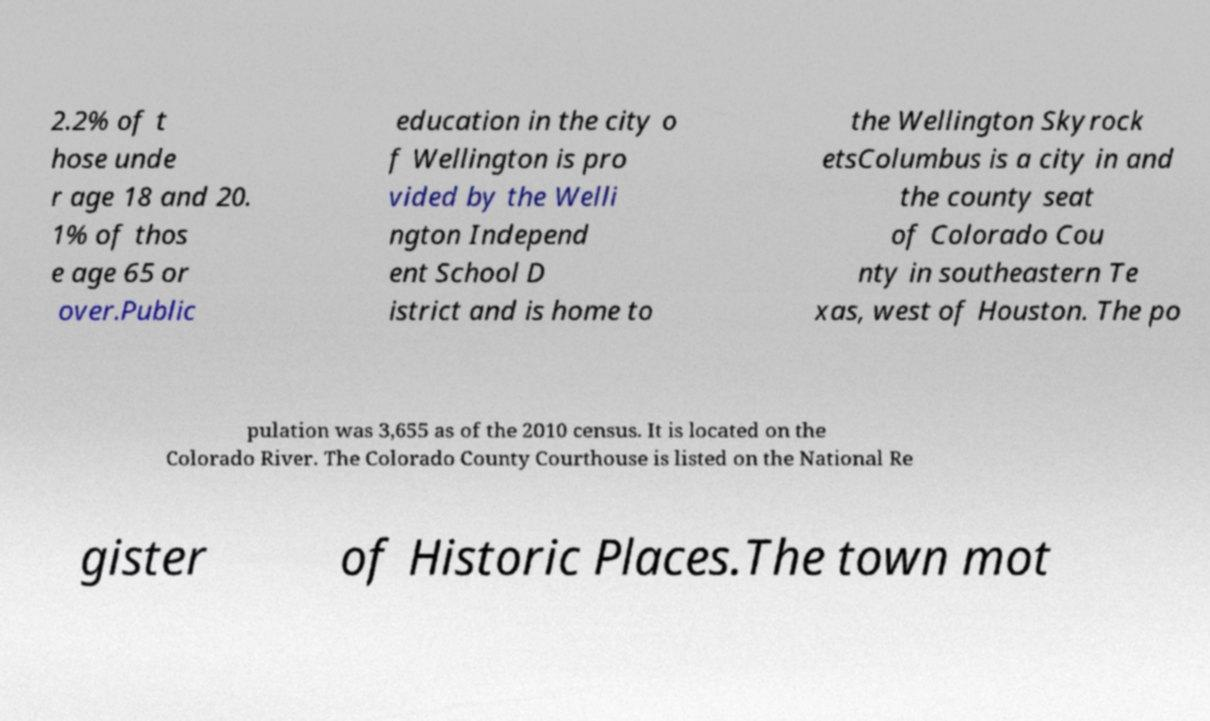Could you assist in decoding the text presented in this image and type it out clearly? 2.2% of t hose unde r age 18 and 20. 1% of thos e age 65 or over.Public education in the city o f Wellington is pro vided by the Welli ngton Independ ent School D istrict and is home to the Wellington Skyrock etsColumbus is a city in and the county seat of Colorado Cou nty in southeastern Te xas, west of Houston. The po pulation was 3,655 as of the 2010 census. It is located on the Colorado River. The Colorado County Courthouse is listed on the National Re gister of Historic Places.The town mot 